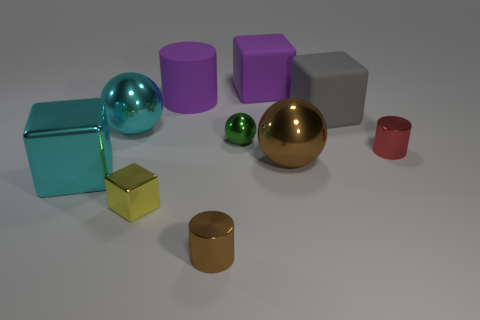Subtract all blocks. How many objects are left? 6 Subtract all large purple rubber cylinders. Subtract all matte cubes. How many objects are left? 7 Add 7 gray rubber things. How many gray rubber things are left? 8 Add 7 brown metallic objects. How many brown metallic objects exist? 9 Subtract 1 red cylinders. How many objects are left? 9 